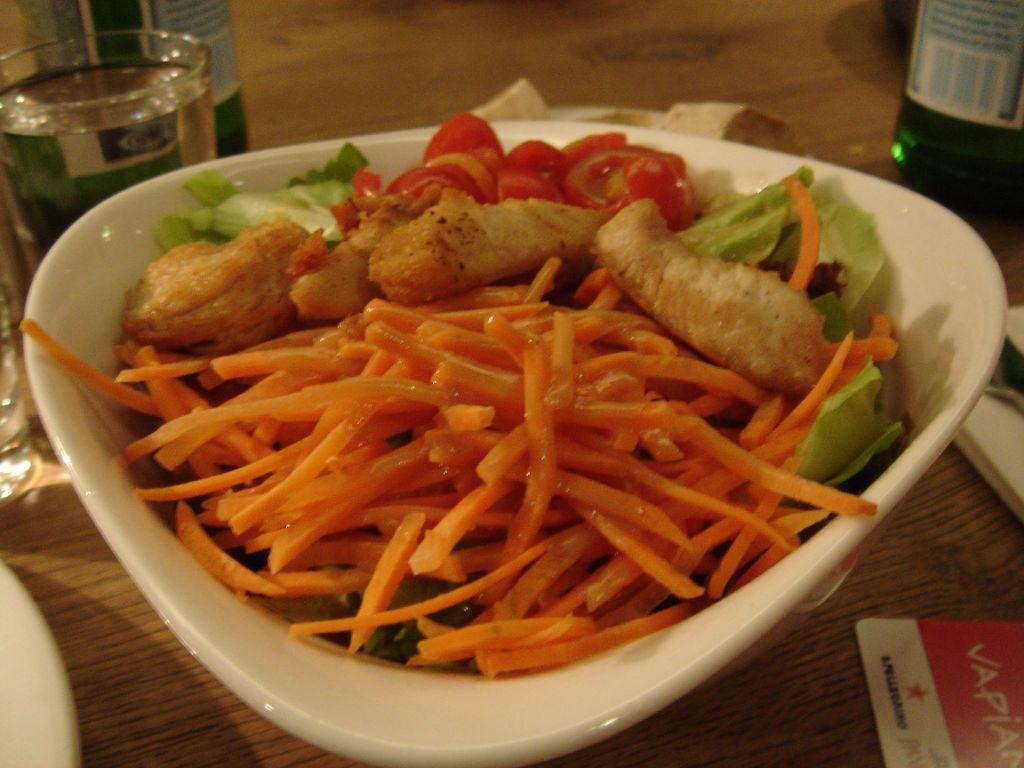What is in the bowl that is visible in the image? There are food items in a bowl in the image. What can be seen in the background of the image? There are glasses in the background of the image. What other objects are present on a surface in the background of the image? There are other objects on a surface in the background of the image. What type of agreement is being discussed by the dog in the image? There is no dog present in the image, so no agreement can be discussed. 